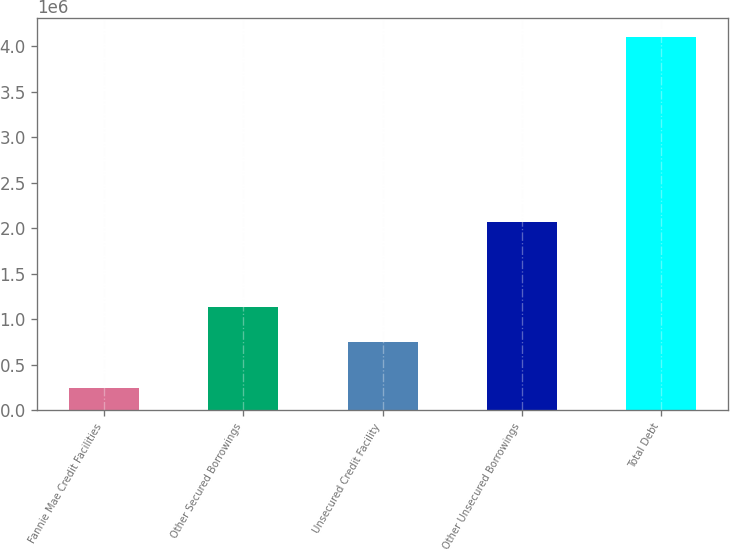Convert chart to OTSL. <chart><loc_0><loc_0><loc_500><loc_500><bar_chart><fcel>Fannie Mae Credit Facilities<fcel>Other Secured Borrowings<fcel>Unsecured Credit Facility<fcel>Other Unsecured Borrowings<fcel>Total Debt<nl><fcel>240000<fcel>1.13626e+06<fcel>750000<fcel>2.06633e+06<fcel>4.10257e+06<nl></chart> 